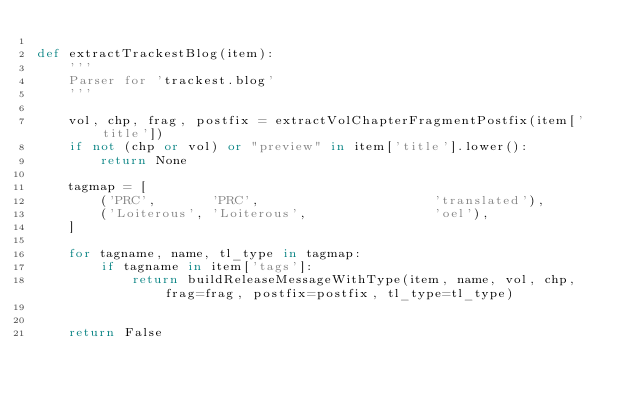Convert code to text. <code><loc_0><loc_0><loc_500><loc_500><_Python_>
def extractTrackestBlog(item):
	'''
	Parser for 'trackest.blog'
	'''

	vol, chp, frag, postfix = extractVolChapterFragmentPostfix(item['title'])
	if not (chp or vol) or "preview" in item['title'].lower():
		return None

	tagmap = [
		('PRC',       'PRC',                      'translated'),
		('Loiterous', 'Loiterous',                'oel'),
	]

	for tagname, name, tl_type in tagmap:
		if tagname in item['tags']:
			return buildReleaseMessageWithType(item, name, vol, chp, frag=frag, postfix=postfix, tl_type=tl_type)


	return False
	</code> 